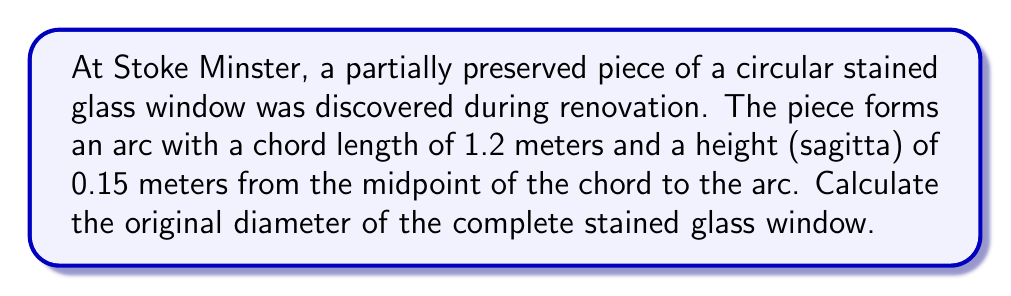Teach me how to tackle this problem. Let's approach this step-by-step:

1) In a circular window, the partially preserved piece forms a circular segment. We can use the chord length and height to determine the radius of the original circle.

2) Let $r$ be the radius of the circle, $c$ be the chord length, and $h$ be the height (sagitta).

3) We can use the formula:

   $$r = \frac{h}{2} + \frac{c^2}{8h}$$

4) Substituting our known values:
   $c = 1.2$ meters
   $h = 0.15$ meters

5) Let's calculate:

   $$r = \frac{0.15}{2} + \frac{1.2^2}{8(0.15)}$$

6) Simplifying:

   $$r = 0.075 + \frac{1.44}{1.2} = 0.075 + 1.2 = 1.275$$

7) Therefore, the radius of the original circle is 1.275 meters.

8) The diameter is twice the radius:

   $$d = 2r = 2(1.275) = 2.55$$ meters

Thus, the original diameter of the stained glass window was 2.55 meters.
Answer: 2.55 meters 